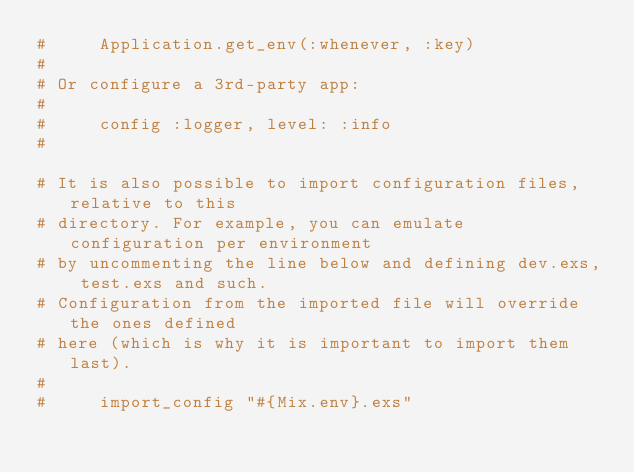<code> <loc_0><loc_0><loc_500><loc_500><_Elixir_>#     Application.get_env(:whenever, :key)
#
# Or configure a 3rd-party app:
#
#     config :logger, level: :info
#

# It is also possible to import configuration files, relative to this
# directory. For example, you can emulate configuration per environment
# by uncommenting the line below and defining dev.exs, test.exs and such.
# Configuration from the imported file will override the ones defined
# here (which is why it is important to import them last).
#
#     import_config "#{Mix.env}.exs"
</code> 